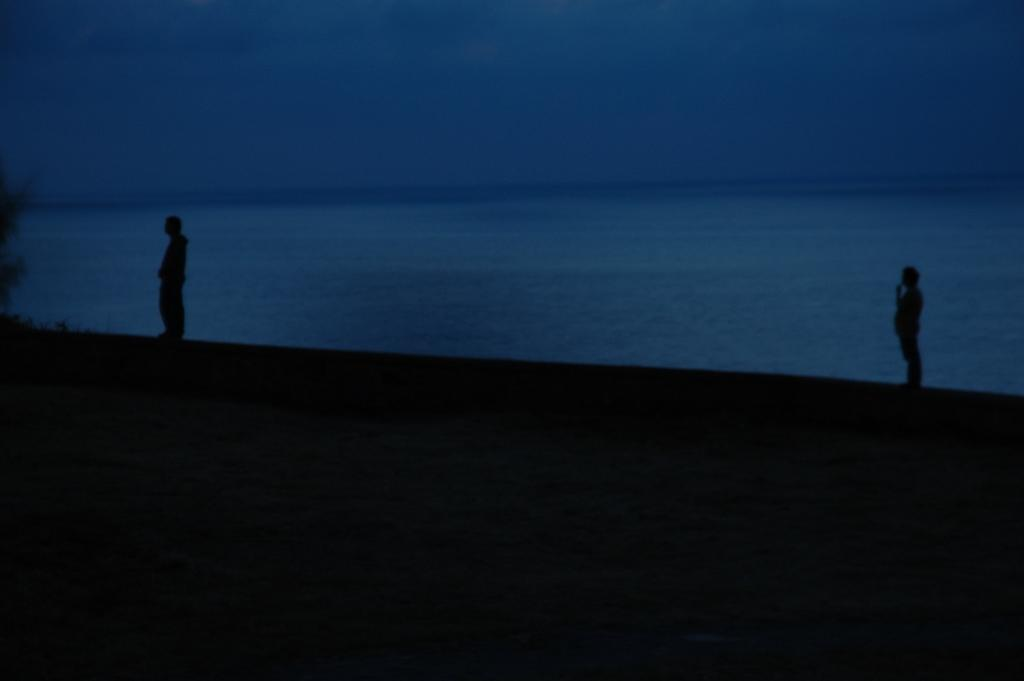How many people are in the image? There are two people standing in the image. What is visible in the background of the image? Water and the sky are visible in the image. What is the lighting condition in the image? The image appears to be slightly dark. What type of cracker is being used to fight in the image? There is no cracker or fighting present in the image. What force is causing the water to move in the image? The image does not show any movement of the water, so it is not possible to determine the cause of any movement. 